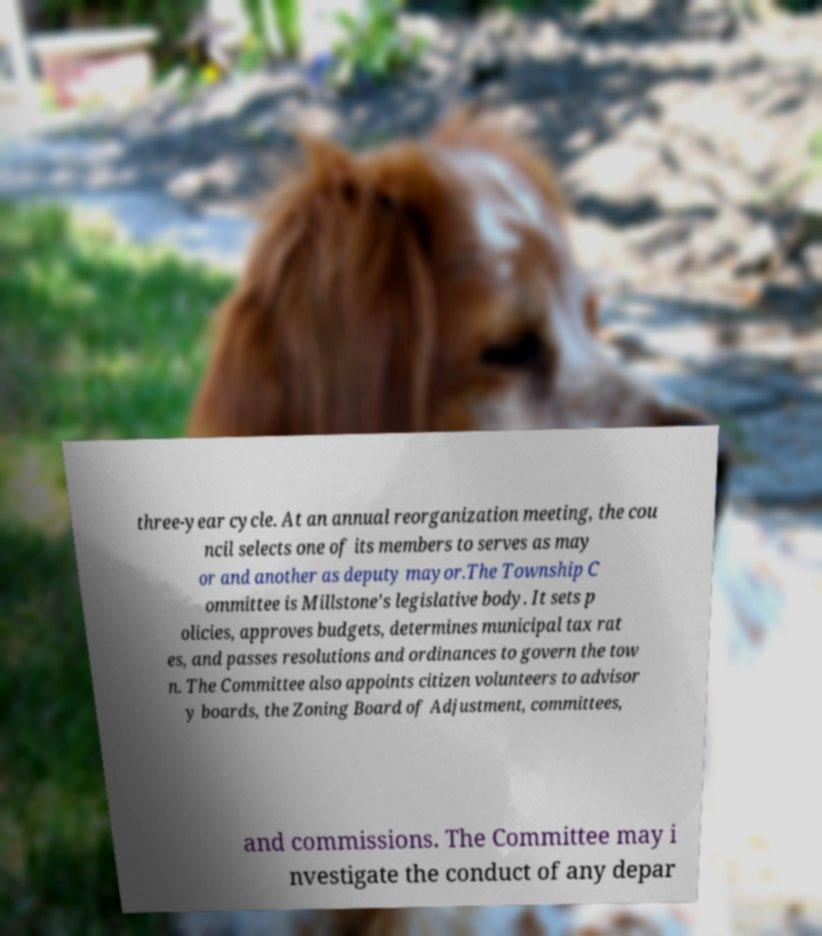Can you accurately transcribe the text from the provided image for me? three-year cycle. At an annual reorganization meeting, the cou ncil selects one of its members to serves as may or and another as deputy mayor.The Township C ommittee is Millstone's legislative body. It sets p olicies, approves budgets, determines municipal tax rat es, and passes resolutions and ordinances to govern the tow n. The Committee also appoints citizen volunteers to advisor y boards, the Zoning Board of Adjustment, committees, and commissions. The Committee may i nvestigate the conduct of any depar 